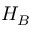Convert formula to latex. <formula><loc_0><loc_0><loc_500><loc_500>H _ { B }</formula> 